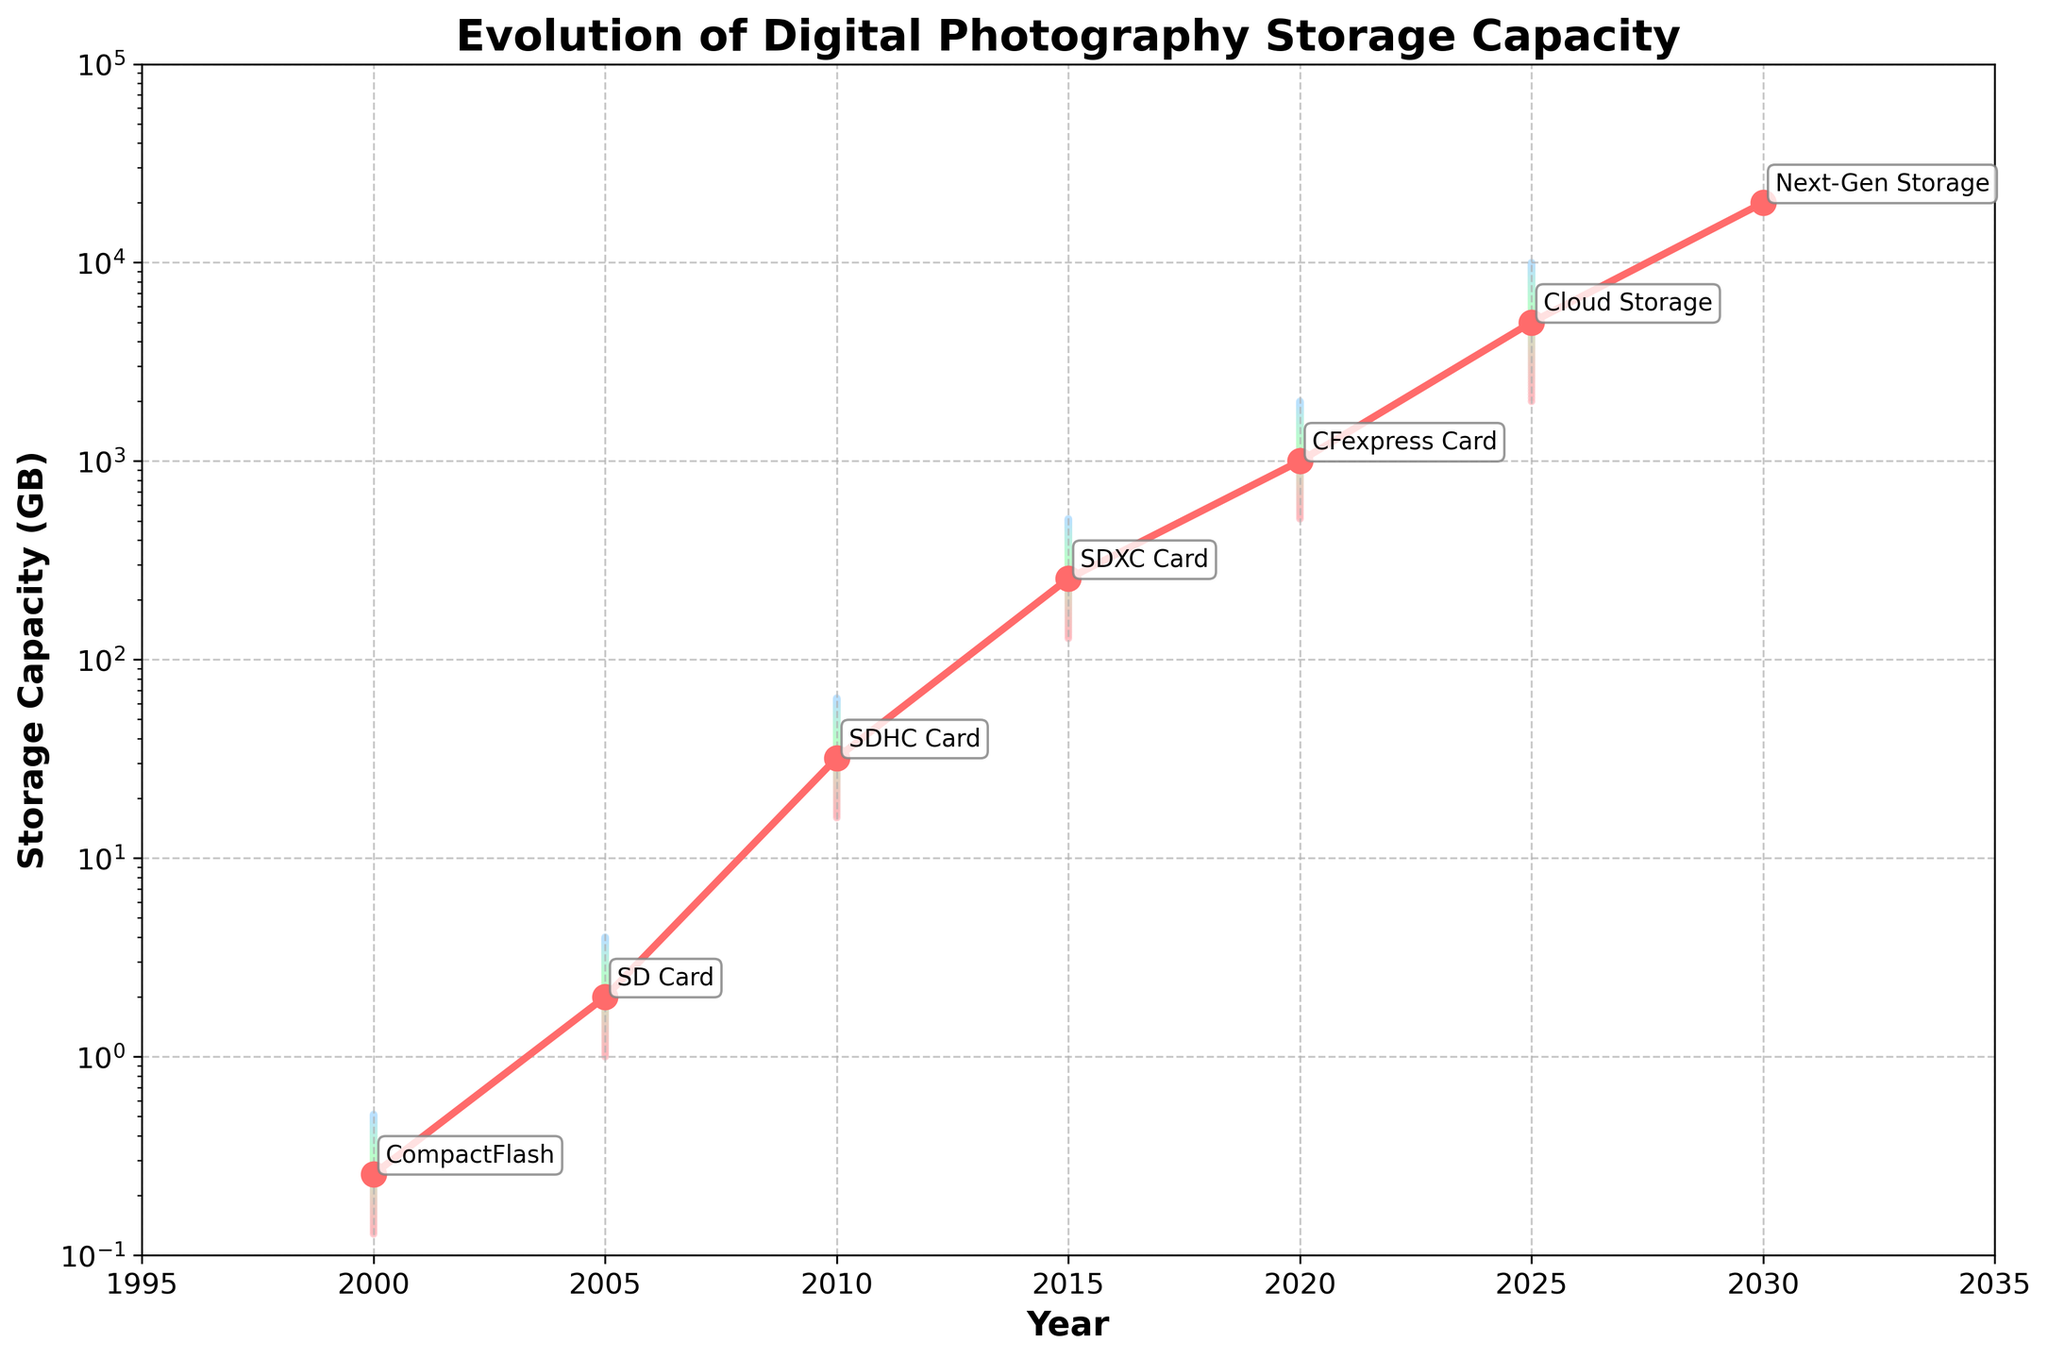What is the title of the chart? The title can be found at the top of the chart, which summarizes the main focus of the figure.
Answer: Evolution of Digital Photography Storage Capacity What is the storage capacity in GB for SDHC cards in 2010? Locate the year 2010 on the x-axis, then look at the corresponding point on the main trend line and read the storage capacity.
Answer: 32 GB Which storage type has the highest estimated storage capacity in 2030 and what is it? Identify the storage type for the year 2030 by looking at the annotations, and read the storage capacity value next to it.
Answer: Next-Gen Storage, 20000 GB What is the color gradient used in the fan chart? Observe the range of colors used in the fan chart and describe them.
Answer: The colors range from light red to light green to light blue By how much did the median storage capacity increase from 2000 to 2020? Find the storage capacities for years 2000 and 2020 on the main trend line, then compute the difference between them. Median capacity for CompactFlash in 2000 is 0.256 GB and for CFexpress Card in 2020 is 1000 GB, so the difference is 1000 - 0.256.
Answer: 999.744 GB What is the upper bound of storage capacity for SDXC cards in 2015? Locate the year 2015 on the x-axis, then read the upper bound value from the fan area for that year.
Answer: 512 GB Which year shows the most substantial jump in storage capacity on the main trend line? Compare the storage capacities year by year on the main trend line to identify where the largest jump occurs. From 2025 to 2030, the jump is 15000 GB (20000 GB - 5000 GB).
Answer: 2025 to 2030 What mathematical scale is used for the y-axis, and why do you think this choice was made? Examine the y-axis to identify its scale and reason why this scale is appropriate for the data displayed.
Answer: Logarithmic scale, to accommodate the large range of storage capacities spanning several orders of magnitude 